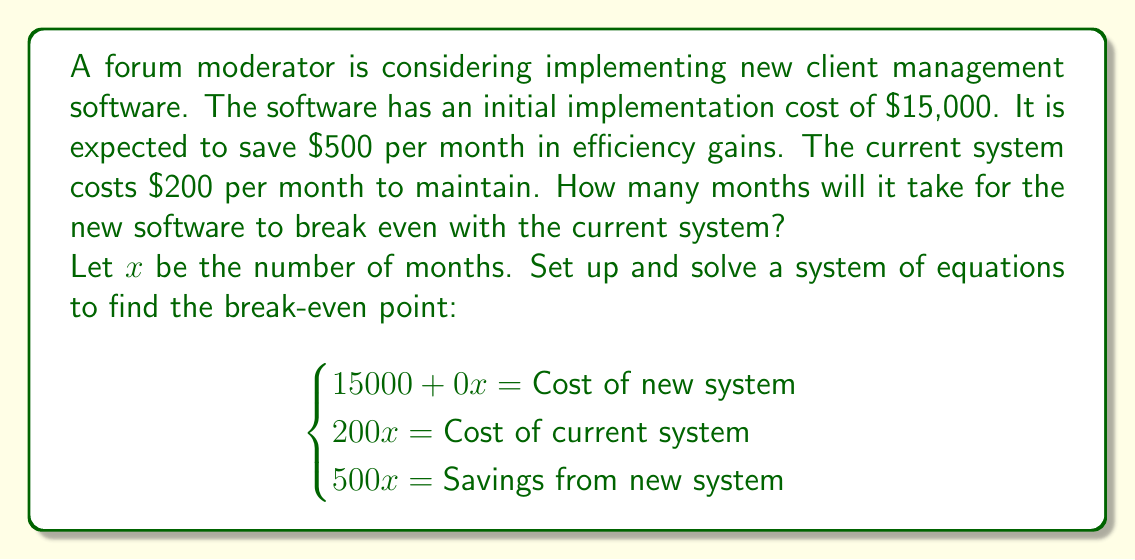Teach me how to tackle this problem. To solve this problem, we need to set up and solve a system of equations:

1) Let's define our equations:
   - Cost of new system: $15000 + 0x$ (initial cost plus $0 monthly cost)
   - Cost of current system: $200x$ ($200 per month)
   - Savings from new system: $500x$ ($500 per month)

2) At the break-even point, the cost of the new system minus the savings should equal the cost of the current system:

   $$(15000 + 0x) - 500x = 200x$$

3) Simplify the equation:
   
   $$15000 - 500x = 200x$$

4) Combine like terms:
   
   $$15000 = 700x$$

5) Solve for $x$:
   
   $$x = \frac{15000}{700} = 21.43$$

6) Since we can't have a fractional month, we round up to the nearest whole month.

Therefore, it will take 22 months for the new software to break even with the current system.
Answer: 22 months 